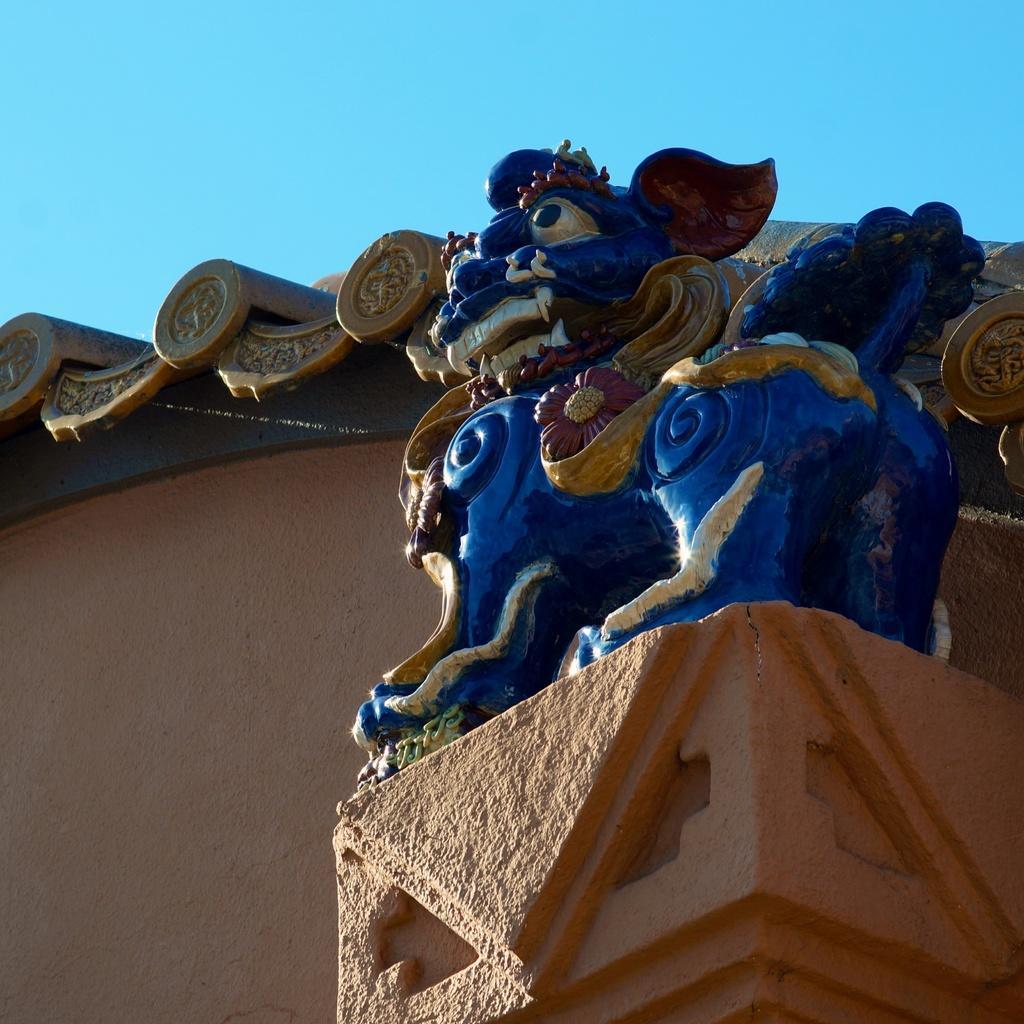How would you summarize this image in a sentence or two? In this image we can see a statue on a pillar. We can also see a wall and the sky. 